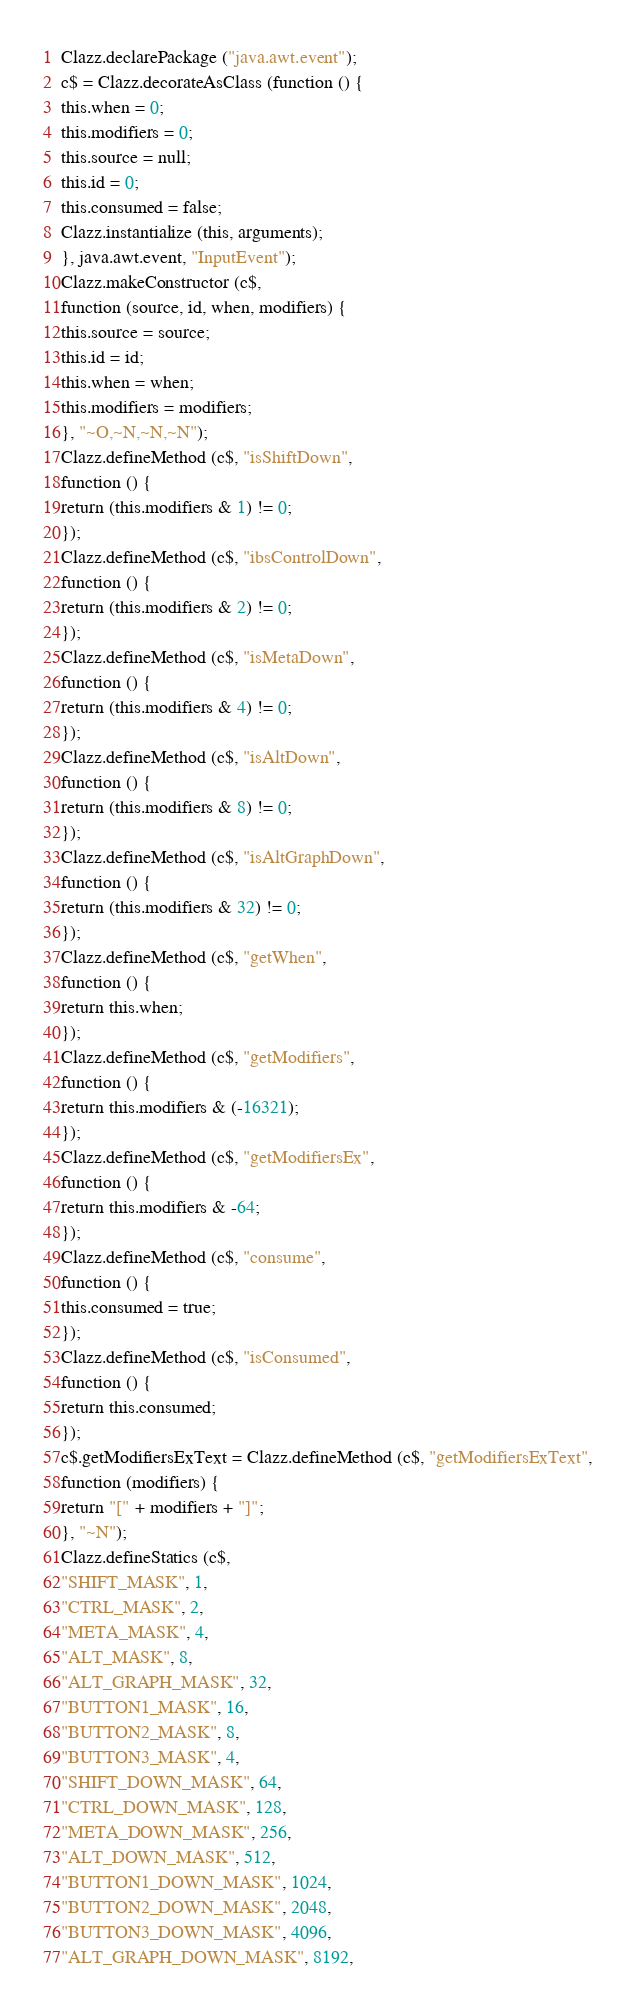<code> <loc_0><loc_0><loc_500><loc_500><_JavaScript_>Clazz.declarePackage ("java.awt.event");
c$ = Clazz.decorateAsClass (function () {
this.when = 0;
this.modifiers = 0;
this.source = null;
this.id = 0;
this.consumed = false;
Clazz.instantialize (this, arguments);
}, java.awt.event, "InputEvent");
Clazz.makeConstructor (c$,
function (source, id, when, modifiers) {
this.source = source;
this.id = id;
this.when = when;
this.modifiers = modifiers;
}, "~O,~N,~N,~N");
Clazz.defineMethod (c$, "isShiftDown",
function () {
return (this.modifiers & 1) != 0;
});
Clazz.defineMethod (c$, "ibsControlDown",
function () {
return (this.modifiers & 2) != 0;
});
Clazz.defineMethod (c$, "isMetaDown",
function () {
return (this.modifiers & 4) != 0;
});
Clazz.defineMethod (c$, "isAltDown",
function () {
return (this.modifiers & 8) != 0;
});
Clazz.defineMethod (c$, "isAltGraphDown",
function () {
return (this.modifiers & 32) != 0;
});
Clazz.defineMethod (c$, "getWhen",
function () {
return this.when;
});
Clazz.defineMethod (c$, "getModifiers",
function () {
return this.modifiers & (-16321);
});
Clazz.defineMethod (c$, "getModifiersEx",
function () {
return this.modifiers & -64;
});
Clazz.defineMethod (c$, "consume",
function () {
this.consumed = true;
});
Clazz.defineMethod (c$, "isConsumed",
function () {
return this.consumed;
});
c$.getModifiersExText = Clazz.defineMethod (c$, "getModifiersExText",
function (modifiers) {
return "[" + modifiers + "]";
}, "~N");
Clazz.defineStatics (c$,
"SHIFT_MASK", 1,
"CTRL_MASK", 2,
"META_MASK", 4,
"ALT_MASK", 8,
"ALT_GRAPH_MASK", 32,
"BUTTON1_MASK", 16,
"BUTTON2_MASK", 8,
"BUTTON3_MASK", 4,
"SHIFT_DOWN_MASK", 64,
"CTRL_DOWN_MASK", 128,
"META_DOWN_MASK", 256,
"ALT_DOWN_MASK", 512,
"BUTTON1_DOWN_MASK", 1024,
"BUTTON2_DOWN_MASK", 2048,
"BUTTON3_DOWN_MASK", 4096,
"ALT_GRAPH_DOWN_MASK", 8192,</code> 